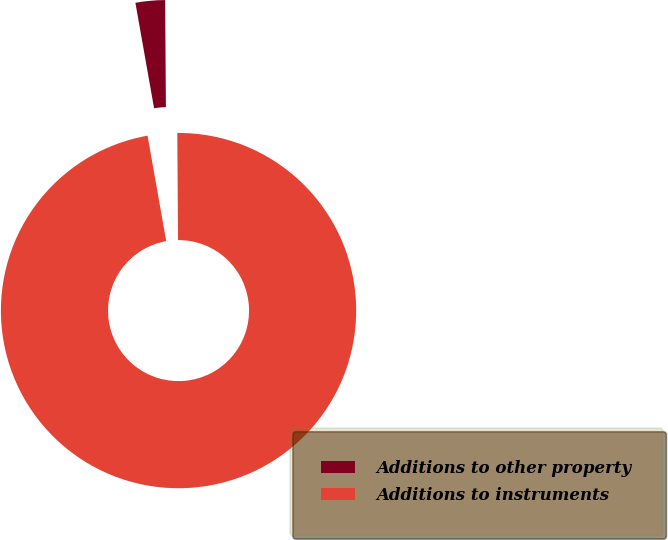Convert chart to OTSL. <chart><loc_0><loc_0><loc_500><loc_500><pie_chart><fcel>Additions to other property<fcel>Additions to instruments<nl><fcel>2.68%<fcel>97.32%<nl></chart> 